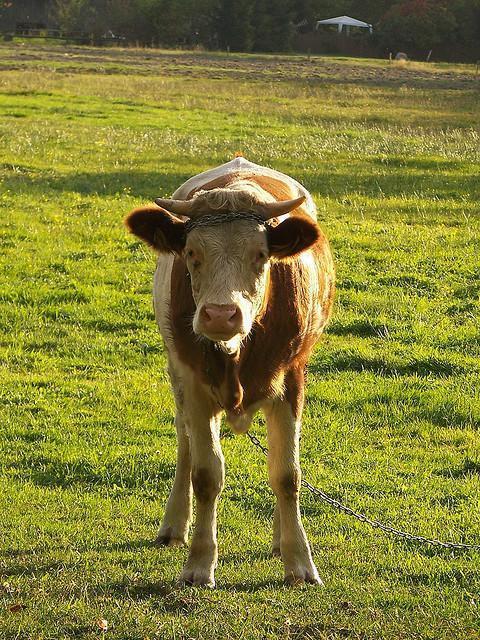How many people in this shot?
Give a very brief answer. 0. 